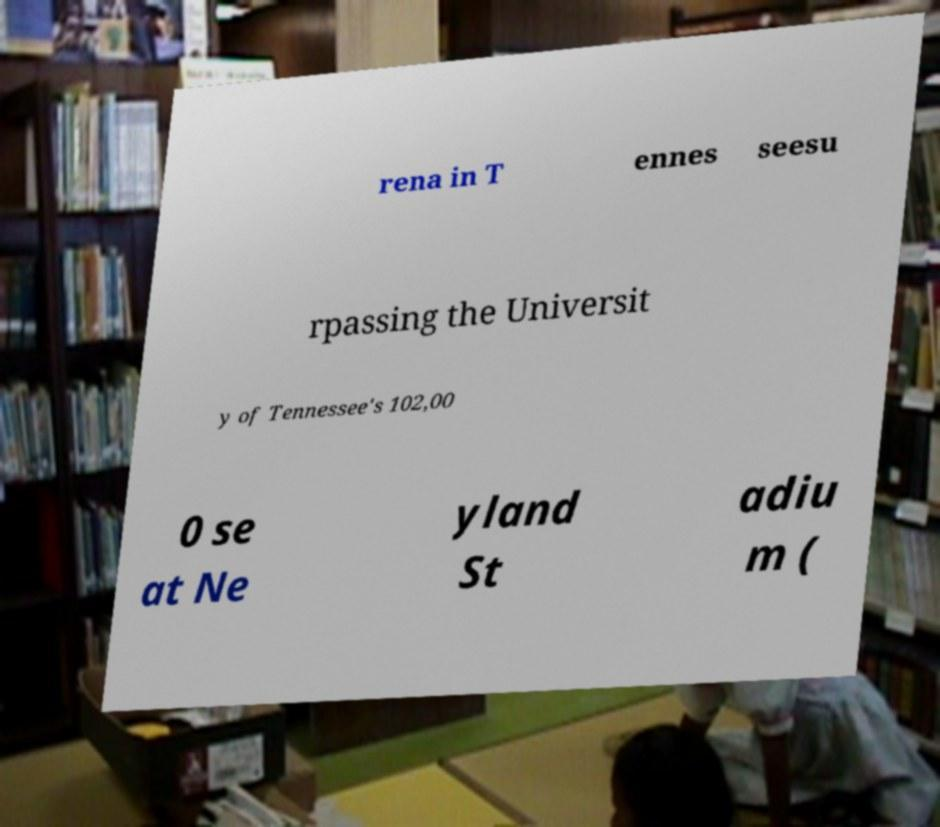Please read and relay the text visible in this image. What does it say? rena in T ennes seesu rpassing the Universit y of Tennessee's 102,00 0 se at Ne yland St adiu m ( 